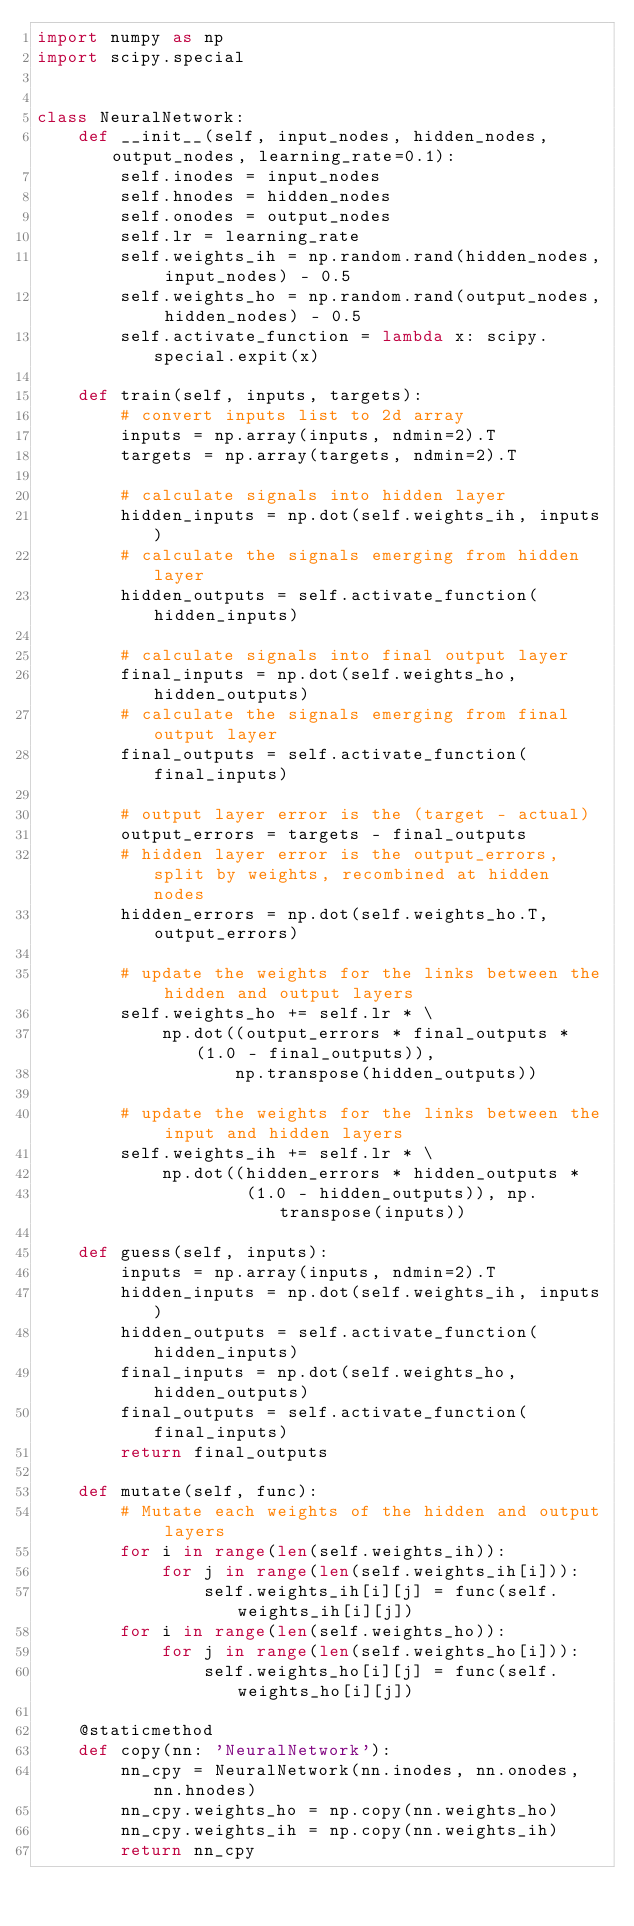<code> <loc_0><loc_0><loc_500><loc_500><_Python_>import numpy as np
import scipy.special


class NeuralNetwork:
    def __init__(self, input_nodes, hidden_nodes, output_nodes, learning_rate=0.1):
        self.inodes = input_nodes
        self.hnodes = hidden_nodes
        self.onodes = output_nodes
        self.lr = learning_rate
        self.weights_ih = np.random.rand(hidden_nodes, input_nodes) - 0.5
        self.weights_ho = np.random.rand(output_nodes, hidden_nodes) - 0.5
        self.activate_function = lambda x: scipy.special.expit(x)

    def train(self, inputs, targets):
        # convert inputs list to 2d array
        inputs = np.array(inputs, ndmin=2).T
        targets = np.array(targets, ndmin=2).T

        # calculate signals into hidden layer
        hidden_inputs = np.dot(self.weights_ih, inputs)
        # calculate the signals emerging from hidden layer
        hidden_outputs = self.activate_function(hidden_inputs)

        # calculate signals into final output layer
        final_inputs = np.dot(self.weights_ho, hidden_outputs)
        # calculate the signals emerging from final output layer
        final_outputs = self.activate_function(final_inputs)

        # output layer error is the (target - actual)
        output_errors = targets - final_outputs
        # hidden layer error is the output_errors, split by weights, recombined at hidden nodes
        hidden_errors = np.dot(self.weights_ho.T, output_errors)

        # update the weights for the links between the hidden and output layers
        self.weights_ho += self.lr * \
            np.dot((output_errors * final_outputs * (1.0 - final_outputs)),
                   np.transpose(hidden_outputs))

        # update the weights for the links between the input and hidden layers
        self.weights_ih += self.lr * \
            np.dot((hidden_errors * hidden_outputs *
                    (1.0 - hidden_outputs)), np.transpose(inputs))

    def guess(self, inputs):
        inputs = np.array(inputs, ndmin=2).T
        hidden_inputs = np.dot(self.weights_ih, inputs)
        hidden_outputs = self.activate_function(hidden_inputs)
        final_inputs = np.dot(self.weights_ho, hidden_outputs)
        final_outputs = self.activate_function(final_inputs)
        return final_outputs

    def mutate(self, func):
        # Mutate each weights of the hidden and output layers
        for i in range(len(self.weights_ih)):
            for j in range(len(self.weights_ih[i])):
                self.weights_ih[i][j] = func(self.weights_ih[i][j])
        for i in range(len(self.weights_ho)):
            for j in range(len(self.weights_ho[i])):
                self.weights_ho[i][j] = func(self.weights_ho[i][j])

    @staticmethod
    def copy(nn: 'NeuralNetwork'):
        nn_cpy = NeuralNetwork(nn.inodes, nn.onodes, nn.hnodes)
        nn_cpy.weights_ho = np.copy(nn.weights_ho)
        nn_cpy.weights_ih = np.copy(nn.weights_ih)
        return nn_cpy
</code> 